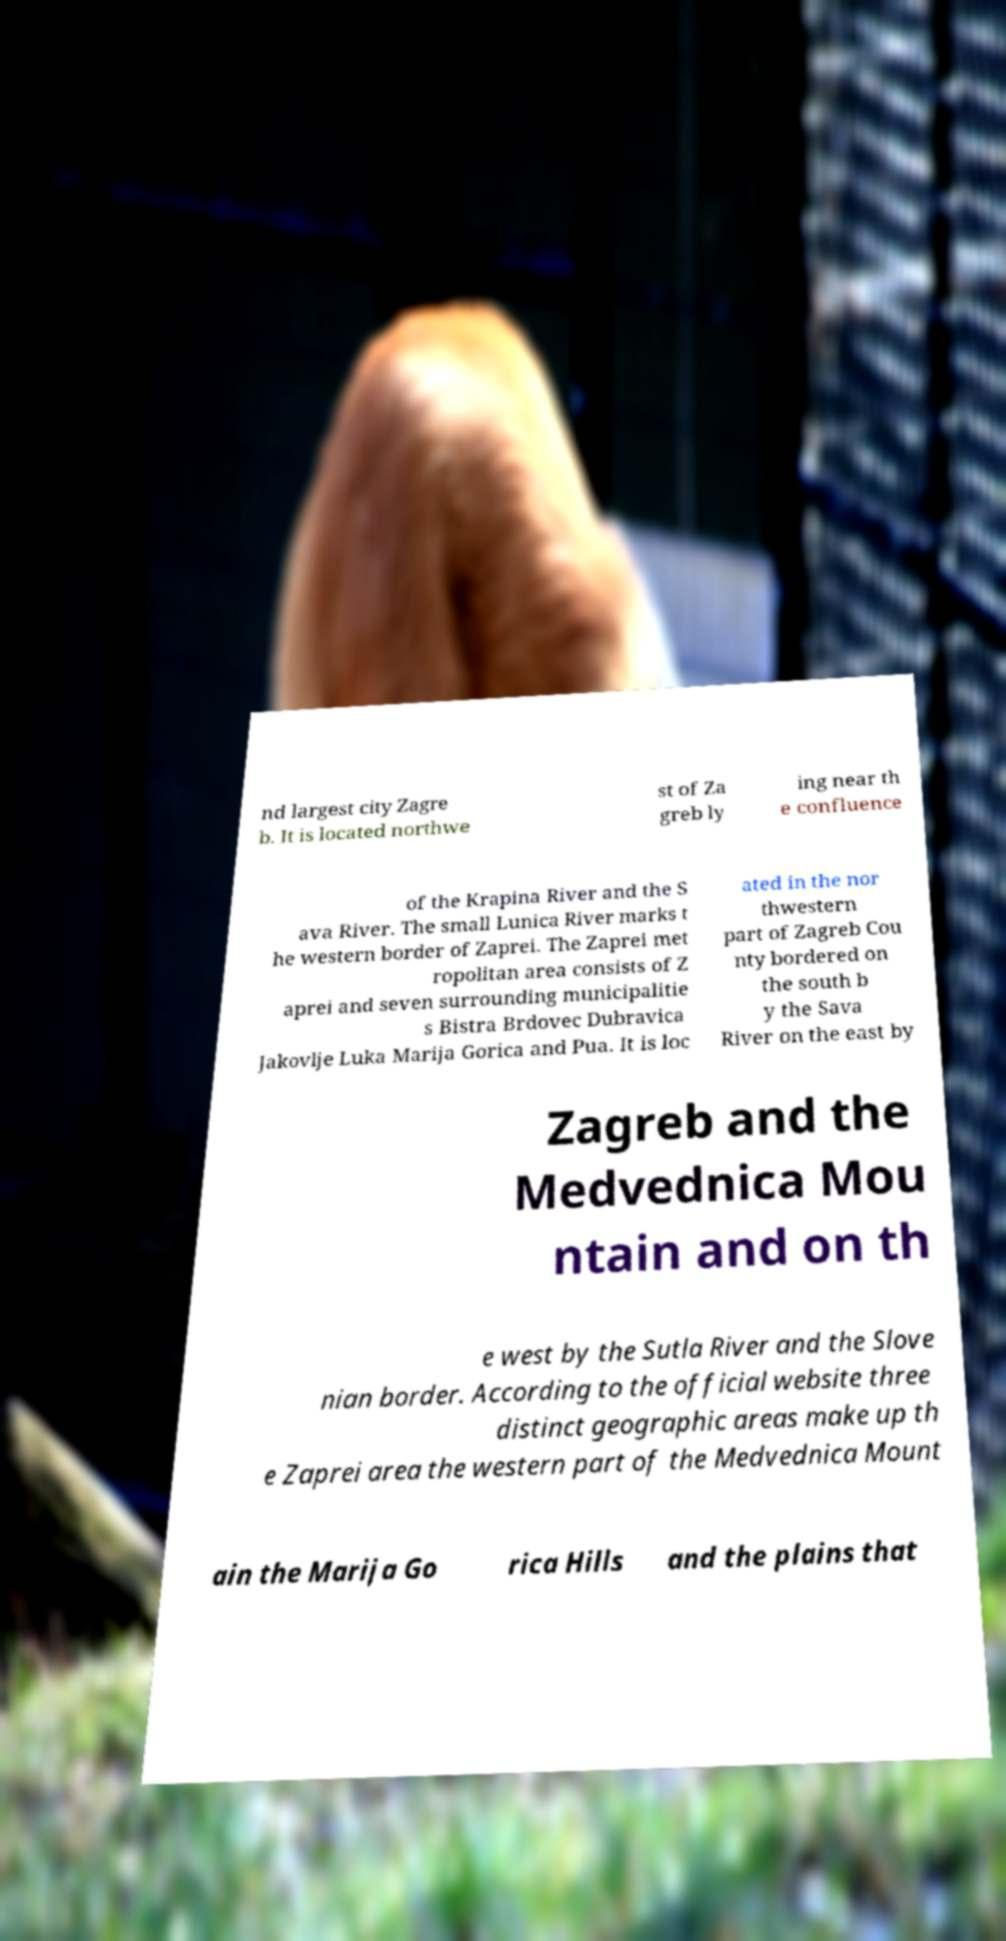Please read and relay the text visible in this image. What does it say? nd largest city Zagre b. It is located northwe st of Za greb ly ing near th e confluence of the Krapina River and the S ava River. The small Lunica River marks t he western border of Zaprei. The Zaprei met ropolitan area consists of Z aprei and seven surrounding municipalitie s Bistra Brdovec Dubravica Jakovlje Luka Marija Gorica and Pua. It is loc ated in the nor thwestern part of Zagreb Cou nty bordered on the south b y the Sava River on the east by Zagreb and the Medvednica Mou ntain and on th e west by the Sutla River and the Slove nian border. According to the official website three distinct geographic areas make up th e Zaprei area the western part of the Medvednica Mount ain the Marija Go rica Hills and the plains that 